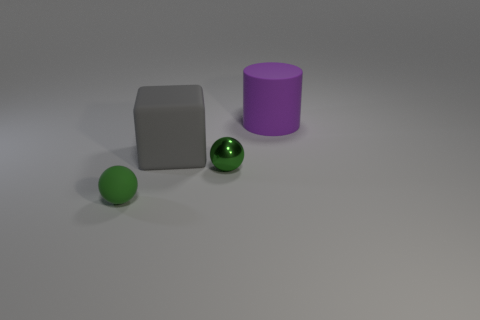How many green spheres must be subtracted to get 1 green spheres? 1 Subtract 1 cylinders. How many cylinders are left? 0 Subtract all green cylinders. Subtract all green blocks. How many cylinders are left? 1 Subtract all small gray rubber cubes. Subtract all green metal objects. How many objects are left? 3 Add 2 tiny metal objects. How many tiny metal objects are left? 3 Add 2 matte cubes. How many matte cubes exist? 3 Add 4 small matte objects. How many objects exist? 8 Subtract 0 yellow balls. How many objects are left? 4 Subtract all cubes. How many objects are left? 3 